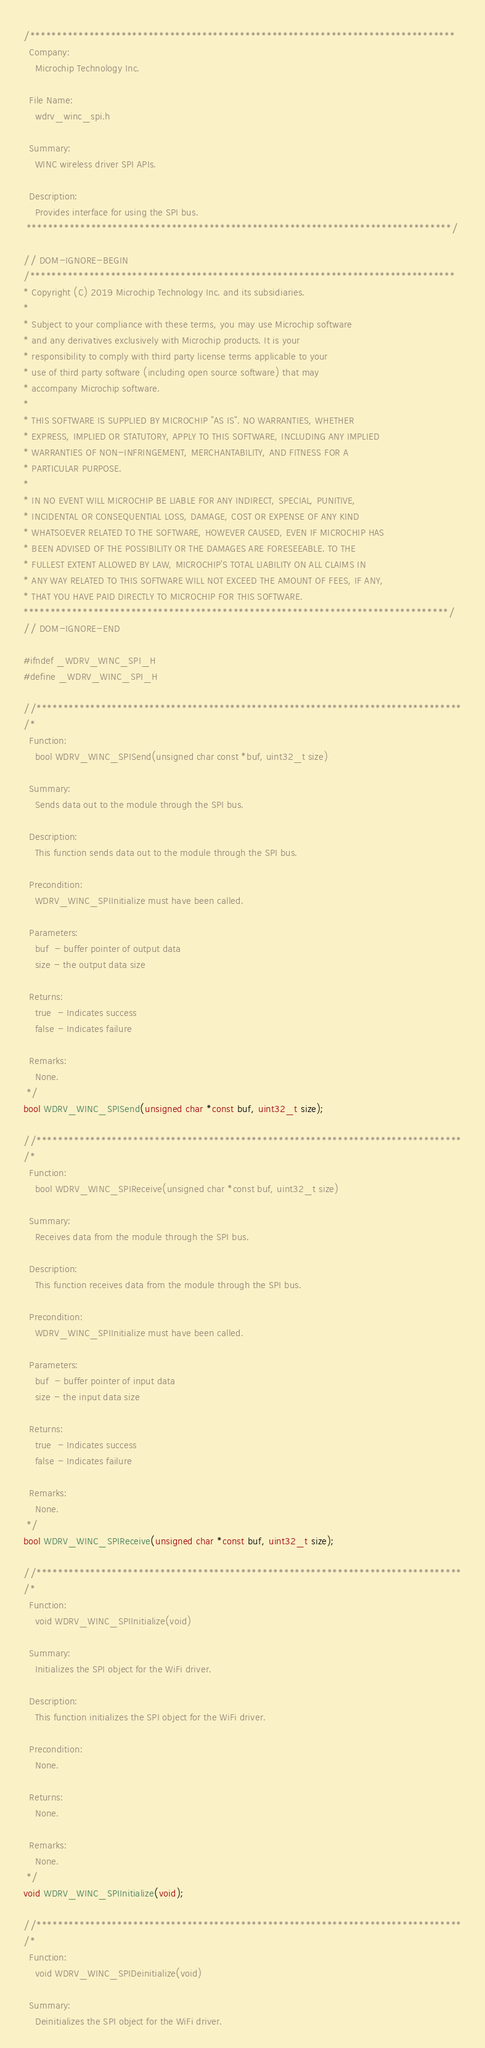<code> <loc_0><loc_0><loc_500><loc_500><_C_>/*******************************************************************************
  Company:
    Microchip Technology Inc.

  File Name:
    wdrv_winc_spi.h

  Summary:
    WINC wireless driver SPI APIs.

  Description:
    Provides interface for using the SPI bus.
 *******************************************************************************/

// DOM-IGNORE-BEGIN
/*******************************************************************************
* Copyright (C) 2019 Microchip Technology Inc. and its subsidiaries.
*
* Subject to your compliance with these terms, you may use Microchip software
* and any derivatives exclusively with Microchip products. It is your
* responsibility to comply with third party license terms applicable to your
* use of third party software (including open source software) that may
* accompany Microchip software.
*
* THIS SOFTWARE IS SUPPLIED BY MICROCHIP "AS IS". NO WARRANTIES, WHETHER
* EXPRESS, IMPLIED OR STATUTORY, APPLY TO THIS SOFTWARE, INCLUDING ANY IMPLIED
* WARRANTIES OF NON-INFRINGEMENT, MERCHANTABILITY, AND FITNESS FOR A
* PARTICULAR PURPOSE.
*
* IN NO EVENT WILL MICROCHIP BE LIABLE FOR ANY INDIRECT, SPECIAL, PUNITIVE,
* INCIDENTAL OR CONSEQUENTIAL LOSS, DAMAGE, COST OR EXPENSE OF ANY KIND
* WHATSOEVER RELATED TO THE SOFTWARE, HOWEVER CAUSED, EVEN IF MICROCHIP HAS
* BEEN ADVISED OF THE POSSIBILITY OR THE DAMAGES ARE FORESEEABLE. TO THE
* FULLEST EXTENT ALLOWED BY LAW, MICROCHIP'S TOTAL LIABILITY ON ALL CLAIMS IN
* ANY WAY RELATED TO THIS SOFTWARE WILL NOT EXCEED THE AMOUNT OF FEES, IF ANY,
* THAT YOU HAVE PAID DIRECTLY TO MICROCHIP FOR THIS SOFTWARE.
*******************************************************************************/
// DOM-IGNORE-END

#ifndef _WDRV_WINC_SPI_H
#define _WDRV_WINC_SPI_H

//*******************************************************************************
/*
  Function:
    bool WDRV_WINC_SPISend(unsigned char const *buf, uint32_t size)

  Summary:
    Sends data out to the module through the SPI bus.

  Description:
    This function sends data out to the module through the SPI bus.

  Precondition:
    WDRV_WINC_SPIInitialize must have been called.

  Parameters:
    buf  - buffer pointer of output data
    size - the output data size

  Returns:
    true  - Indicates success
    false - Indicates failure

  Remarks:
    None.
 */
bool WDRV_WINC_SPISend(unsigned char *const buf, uint32_t size);

//*******************************************************************************
/*
  Function:
    bool WDRV_WINC_SPIReceive(unsigned char *const buf, uint32_t size)

  Summary:
    Receives data from the module through the SPI bus.

  Description:
    This function receives data from the module through the SPI bus.

  Precondition:
    WDRV_WINC_SPIInitialize must have been called.

  Parameters:
    buf  - buffer pointer of input data
    size - the input data size

  Returns:
    true  - Indicates success
    false - Indicates failure

  Remarks:
    None.
 */
bool WDRV_WINC_SPIReceive(unsigned char *const buf, uint32_t size);

//*******************************************************************************
/*
  Function:
    void WDRV_WINC_SPIInitialize(void)

  Summary:
    Initializes the SPI object for the WiFi driver.

  Description:
    This function initializes the SPI object for the WiFi driver.

  Precondition:
    None.

  Returns:
    None.

  Remarks:
    None.
 */
void WDRV_WINC_SPIInitialize(void);

//*******************************************************************************
/*
  Function:
    void WDRV_WINC_SPIDeinitialize(void)

  Summary:
    Deinitializes the SPI object for the WiFi driver.
</code> 